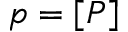Convert formula to latex. <formula><loc_0><loc_0><loc_500><loc_500>p = [ P ]</formula> 